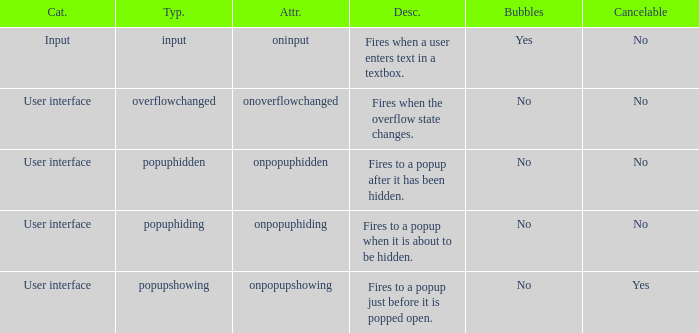What's the cancelable with bubbles being yes No. Can you parse all the data within this table? {'header': ['Cat.', 'Typ.', 'Attr.', 'Desc.', 'Bubbles', 'Cancelable'], 'rows': [['Input', 'input', 'oninput', 'Fires when a user enters text in a textbox.', 'Yes', 'No'], ['User interface', 'overflowchanged', 'onoverflowchanged', 'Fires when the overflow state changes.', 'No', 'No'], ['User interface', 'popuphidden', 'onpopuphidden', 'Fires to a popup after it has been hidden.', 'No', 'No'], ['User interface', 'popuphiding', 'onpopuphiding', 'Fires to a popup when it is about to be hidden.', 'No', 'No'], ['User interface', 'popupshowing', 'onpopupshowing', 'Fires to a popup just before it is popped open.', 'No', 'Yes']]} 